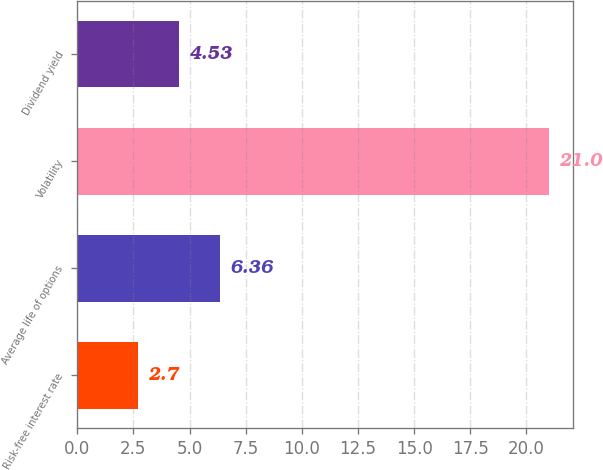Convert chart to OTSL. <chart><loc_0><loc_0><loc_500><loc_500><bar_chart><fcel>Risk-free interest rate<fcel>Average life of options<fcel>Volatility<fcel>Dividend yield<nl><fcel>2.7<fcel>6.36<fcel>21<fcel>4.53<nl></chart> 